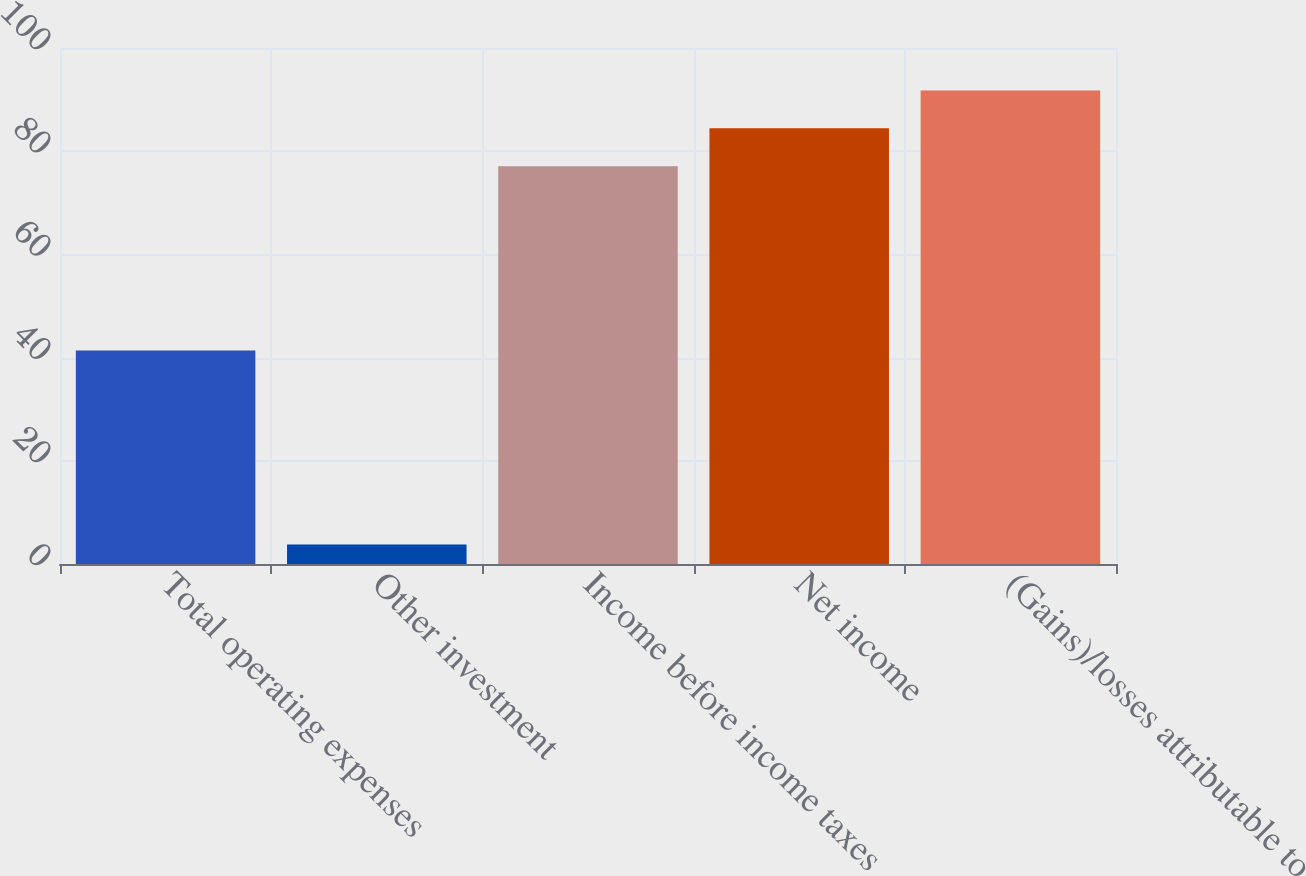Convert chart to OTSL. <chart><loc_0><loc_0><loc_500><loc_500><bar_chart><fcel>Total operating expenses<fcel>Other investment<fcel>Income before income taxes<fcel>Net income<fcel>(Gains)/losses attributable to<nl><fcel>41.4<fcel>3.8<fcel>77.1<fcel>84.43<fcel>91.76<nl></chart> 